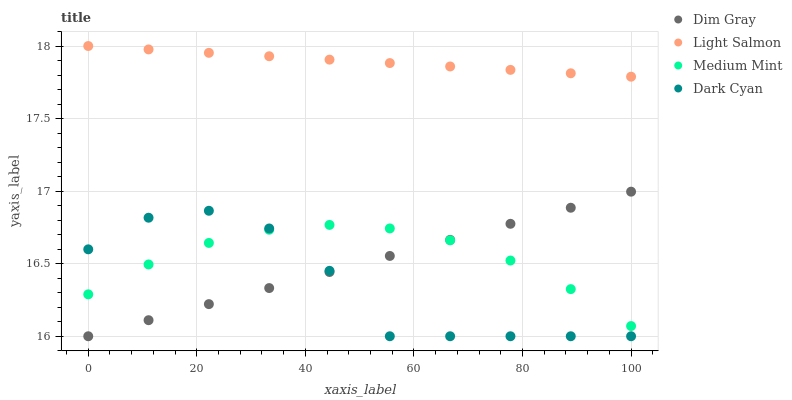Does Dark Cyan have the minimum area under the curve?
Answer yes or no. Yes. Does Light Salmon have the maximum area under the curve?
Answer yes or no. Yes. Does Light Salmon have the minimum area under the curve?
Answer yes or no. No. Does Dark Cyan have the maximum area under the curve?
Answer yes or no. No. Is Light Salmon the smoothest?
Answer yes or no. Yes. Is Dark Cyan the roughest?
Answer yes or no. Yes. Is Dark Cyan the smoothest?
Answer yes or no. No. Is Light Salmon the roughest?
Answer yes or no. No. Does Dark Cyan have the lowest value?
Answer yes or no. Yes. Does Light Salmon have the lowest value?
Answer yes or no. No. Does Light Salmon have the highest value?
Answer yes or no. Yes. Does Dark Cyan have the highest value?
Answer yes or no. No. Is Dim Gray less than Light Salmon?
Answer yes or no. Yes. Is Light Salmon greater than Dim Gray?
Answer yes or no. Yes. Does Medium Mint intersect Dim Gray?
Answer yes or no. Yes. Is Medium Mint less than Dim Gray?
Answer yes or no. No. Is Medium Mint greater than Dim Gray?
Answer yes or no. No. Does Dim Gray intersect Light Salmon?
Answer yes or no. No. 